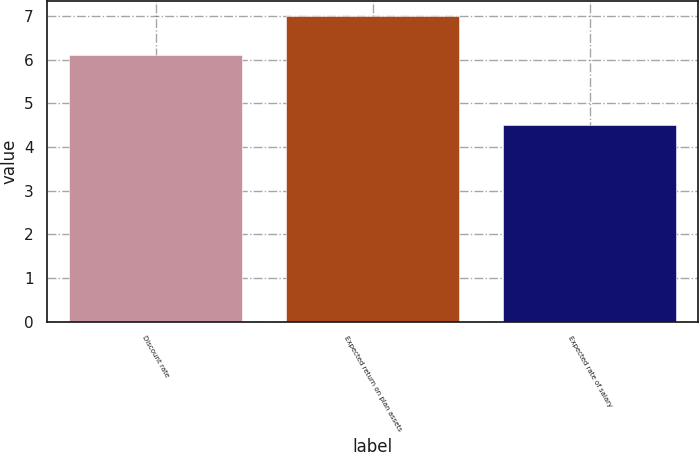Convert chart. <chart><loc_0><loc_0><loc_500><loc_500><bar_chart><fcel>Discount rate<fcel>Expected return on plan assets<fcel>Expected rate of salary<nl><fcel>6.1<fcel>7<fcel>4.5<nl></chart> 